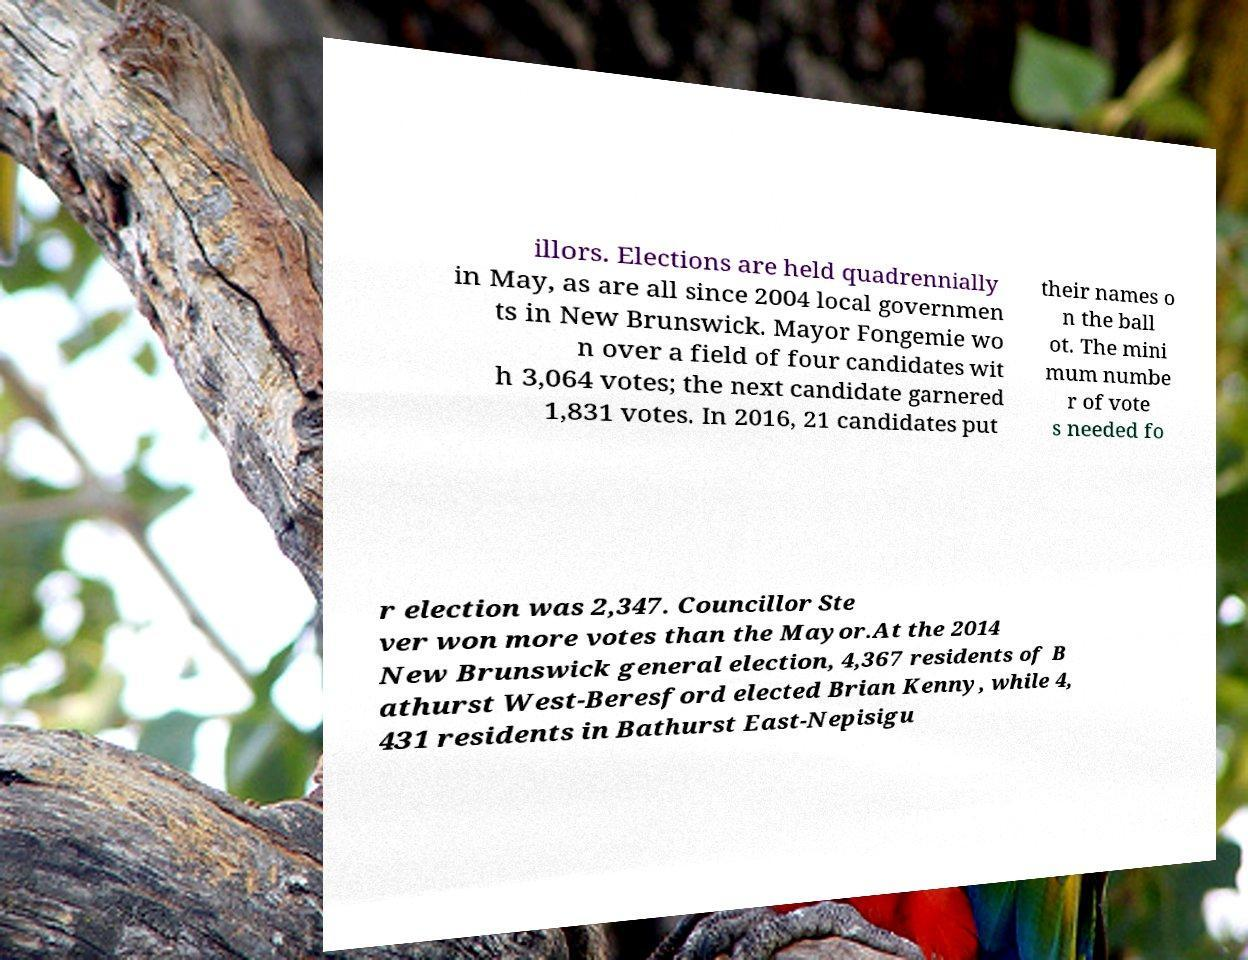Could you extract and type out the text from this image? illors. Elections are held quadrennially in May, as are all since 2004 local governmen ts in New Brunswick. Mayor Fongemie wo n over a field of four candidates wit h 3,064 votes; the next candidate garnered 1,831 votes. In 2016, 21 candidates put their names o n the ball ot. The mini mum numbe r of vote s needed fo r election was 2,347. Councillor Ste ver won more votes than the Mayor.At the 2014 New Brunswick general election, 4,367 residents of B athurst West-Beresford elected Brian Kenny, while 4, 431 residents in Bathurst East-Nepisigu 